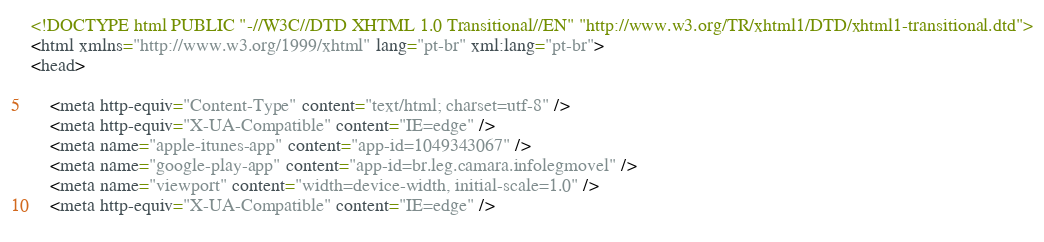<code> <loc_0><loc_0><loc_500><loc_500><_HTML_>




<!DOCTYPE html PUBLIC "-//W3C//DTD XHTML 1.0 Transitional//EN" "http://www.w3.org/TR/xhtml1/DTD/xhtml1-transitional.dtd">
<html xmlns="http://www.w3.org/1999/xhtml" lang="pt-br" xml:lang="pt-br">
<head>
	    
    <meta http-equiv="Content-Type" content="text/html; charset=utf-8" />
    <meta http-equiv="X-UA-Compatible" content="IE=edge" />
    <meta name="apple-itunes-app" content="app-id=1049343067" />
    <meta name="google-play-app" content="app-id=br.leg.camara.infolegmovel" />
    <meta name="viewport" content="width=device-width, initial-scale=1.0" />
	<meta http-equiv="X-UA-Compatible" content="IE=edge" /> 
    </code> 